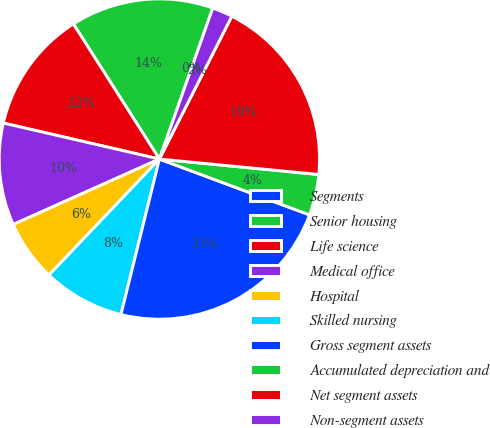Convert chart to OTSL. <chart><loc_0><loc_0><loc_500><loc_500><pie_chart><fcel>Segments<fcel>Senior housing<fcel>Life science<fcel>Medical office<fcel>Hospital<fcel>Skilled nursing<fcel>Gross segment assets<fcel>Accumulated depreciation and<fcel>Net segment assets<fcel>Non-segment assets<nl><fcel>0.0%<fcel>14.43%<fcel>12.37%<fcel>10.31%<fcel>6.19%<fcel>8.25%<fcel>23.19%<fcel>4.13%<fcel>19.07%<fcel>2.06%<nl></chart> 